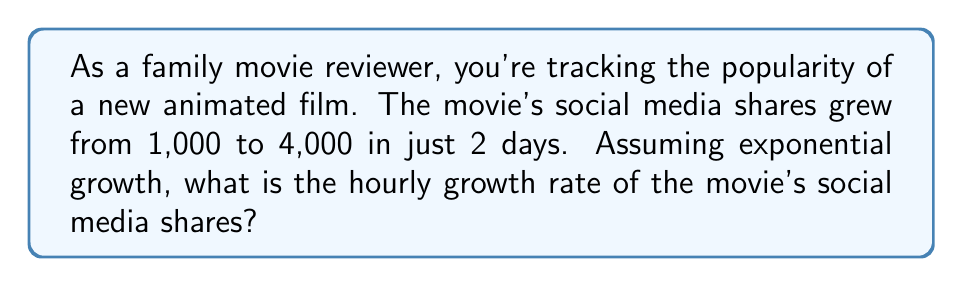Can you answer this question? Let's approach this step-by-step:

1) The exponential growth formula is:
   $$A = P(1 + r)^t$$
   Where:
   $A$ = Final amount
   $P$ = Initial amount
   $r$ = Growth rate (per unit time)
   $t$ = Time

2) We know:
   $P = 1,000$ (initial shares)
   $A = 4,000$ (final shares)
   $t = 48$ (hours in 2 days)

3) Let's plug these into our formula:
   $$4,000 = 1,000(1 + r)^{48}$$

4) Simplify:
   $$4 = (1 + r)^{48}$$

5) Take the 48th root of both sides:
   $$\sqrt[48]{4} = 1 + r$$

6) Solve for $r$:
   $$r = \sqrt[48]{4} - 1$$

7) Calculate:
   $$r \approx 1.0292 - 1 = 0.0292$$

8) Convert to percentage:
   $$r \approx 2.92\%$$
Answer: $2.92\%$ per hour 